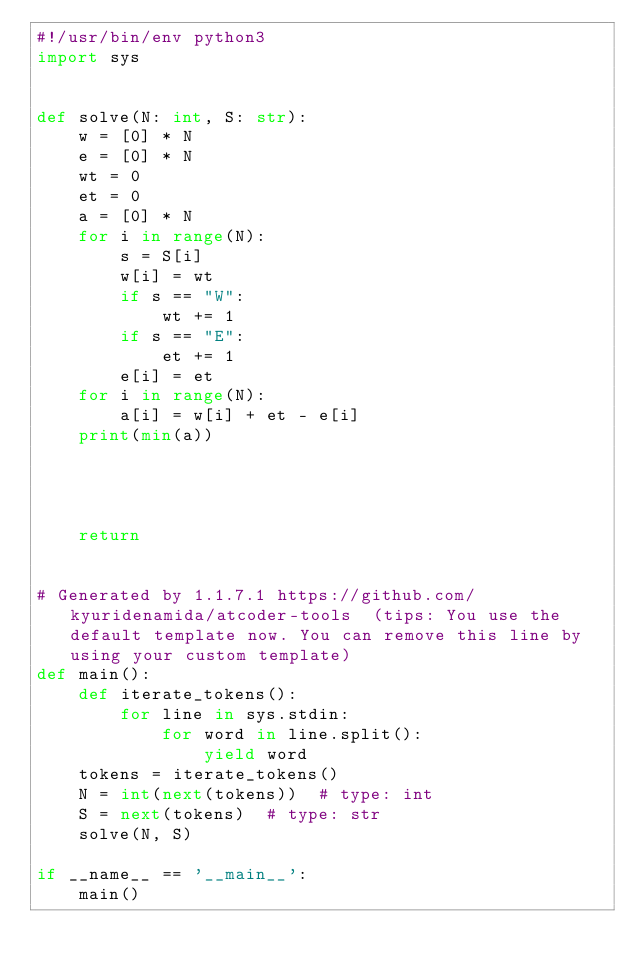<code> <loc_0><loc_0><loc_500><loc_500><_Python_>#!/usr/bin/env python3
import sys


def solve(N: int, S: str):
    w = [0] * N
    e = [0] * N
    wt = 0
    et = 0
    a = [0] * N
    for i in range(N):
        s = S[i]
        w[i] = wt
        if s == "W":
            wt += 1
        if s == "E":
            et += 1
        e[i] = et
    for i in range(N):
        a[i] = w[i] + et - e[i]
    print(min(a))




    return


# Generated by 1.1.7.1 https://github.com/kyuridenamida/atcoder-tools  (tips: You use the default template now. You can remove this line by using your custom template)
def main():
    def iterate_tokens():
        for line in sys.stdin:
            for word in line.split():
                yield word
    tokens = iterate_tokens()
    N = int(next(tokens))  # type: int
    S = next(tokens)  # type: str
    solve(N, S)

if __name__ == '__main__':
    main()
</code> 